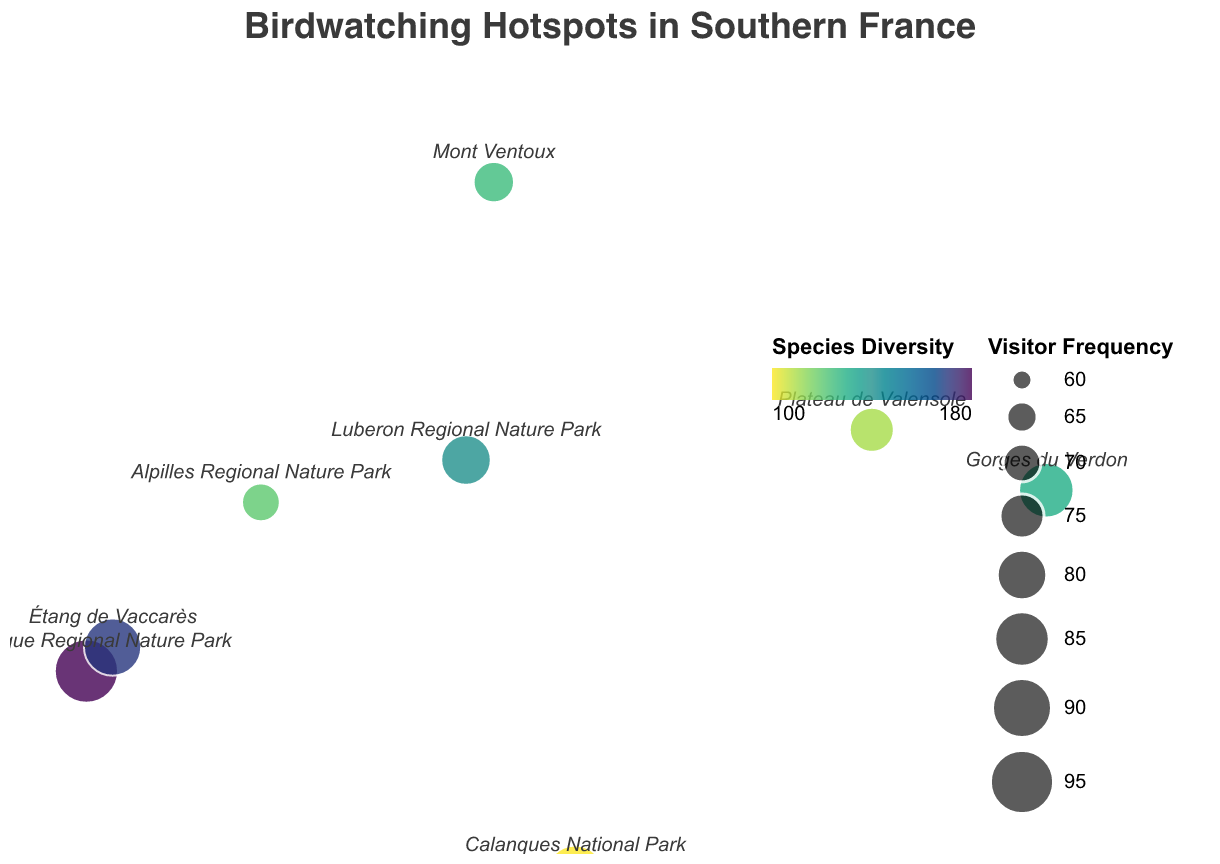What's the hotspot with the highest species diversity? The hotspot with the highest species diversity can be identified by looking for the data point with the deepest color, which represents higher diversity. Camargue Regional Nature Park has the highest species diversity with a value of 180.
Answer: Camargue Regional Nature Park Which location has the highest visitor frequency and what is its value? The location with the highest visitor frequency will have the largest circle on the plot. Camargue Regional Nature Park is the largest circle, indicating the highest visitor frequency of 95.
Answer: Camargue Regional Nature Park, 95 What is the average species diversity across all hotspots? To calculate the average species diversity, sum all species diversity values and divide by the number of hotspots. (180 + 110 + 130 + 140 + 120 + 150 + 100 + 160 + 170 + 125) / 10 = 138.5.
Answer: 138.5 Which location is characterized by the highest species diversity but doesn't have the highest visitor frequency? Identify the location with the color representing high species diversity and compare its circle size to determine its visitor frequency. Camargue Regional Nature Park has the highest species diversity but also the highest visitor frequency. The next highest species diversity is at Étang de Vaccarès with 170 and without the highest visitor frequency.
Answer: Étang de Vaccarès What are the latitude and longitude of Mercantour National Park? Mercantour National Park's position can be identified by looking at the encoded latitude and longitude values. Its latitude is 44.1500 and longitude is 7.2000.
Answer: 44.1500, 7.2000 Which birdwatching hotspot has the lowest visitor frequency and what is its value? The location with the smallest circle represents the lowest visitor frequency. Cévennes National Park has the smallest circle with a visitor frequency of 60.
Answer: Cévennes National Park, 60 What is the difference in visitor frequency between Calanques National Park and Plateau de Valensole? Subtract the visitor frequency value of Plateau de Valensole from Calanques National Park. 90 (Calanques National Park) - 75 (Plateau de Valensole) = 15.
Answer: 15 Which hotspot is geographically positioned the furthest northeast? Identify the point with the highest latitude and longitude values. Mercantour National Park is positioned at 44.1500 latitude and 7.2000 longitude, furthest northeast.
Answer: Mercantour National Park Among Luberon Regional Nature Park, Mont Ventoux, and Alpilles Regional Nature Park, which has the highest species diversity? Compare the species diversity values of the three hotspots. Luberon Regional Nature Park: 140, Mont Ventoux: 125, and Alpilles Regional Nature Park: 120. Luberon Regional Nature Park has the highest species diversity.
Answer: Luberon Regional Nature Park What is the median visitor frequency among all hotspots? Arrange the visitor frequencies in ascending order and find the middle value. The frequencies are 60, 65, 70, 72, 75, 80, 85, 88, 90, 95. The middle value or median is the average of the 5th and 6th values: (75 + 80) / 2 = 77.5.
Answer: 77.5 